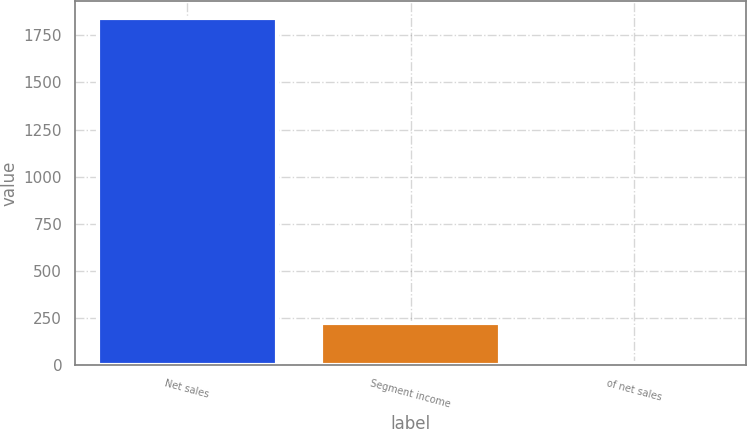Convert chart. <chart><loc_0><loc_0><loc_500><loc_500><bar_chart><fcel>Net sales<fcel>Segment income<fcel>of net sales<nl><fcel>1840.1<fcel>223<fcel>12.1<nl></chart> 